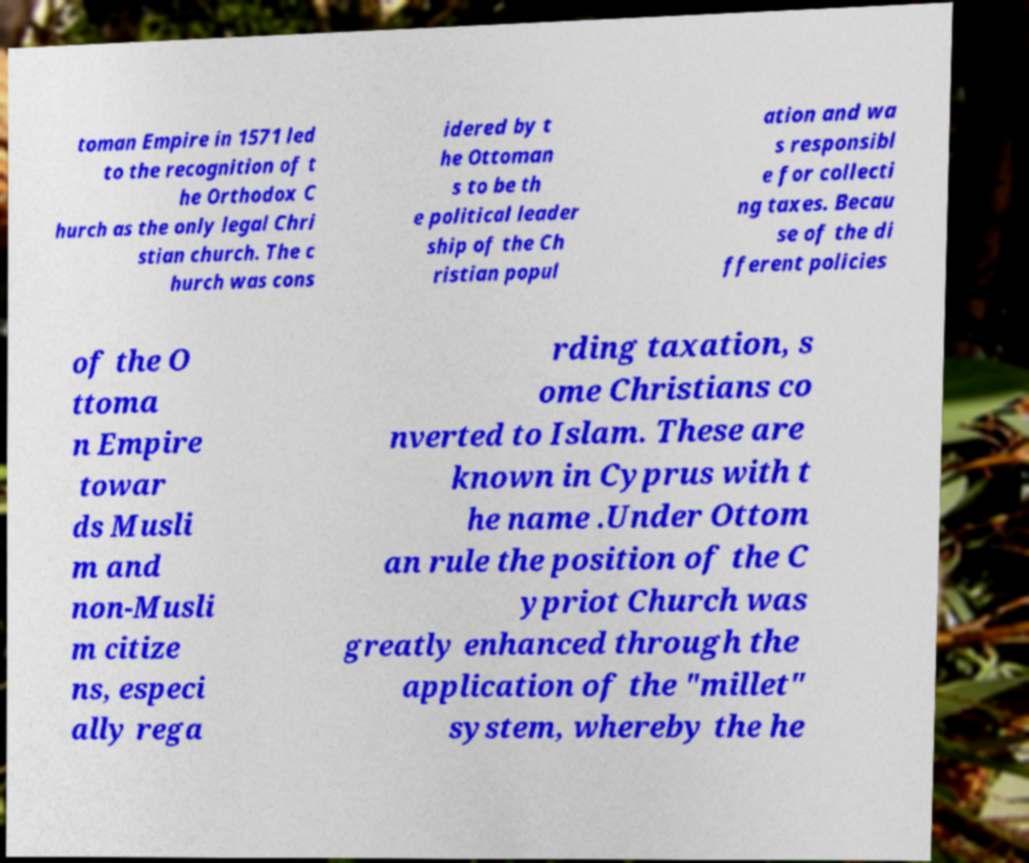For documentation purposes, I need the text within this image transcribed. Could you provide that? toman Empire in 1571 led to the recognition of t he Orthodox C hurch as the only legal Chri stian church. The c hurch was cons idered by t he Ottoman s to be th e political leader ship of the Ch ristian popul ation and wa s responsibl e for collecti ng taxes. Becau se of the di fferent policies of the O ttoma n Empire towar ds Musli m and non-Musli m citize ns, especi ally rega rding taxation, s ome Christians co nverted to Islam. These are known in Cyprus with t he name .Under Ottom an rule the position of the C ypriot Church was greatly enhanced through the application of the "millet" system, whereby the he 